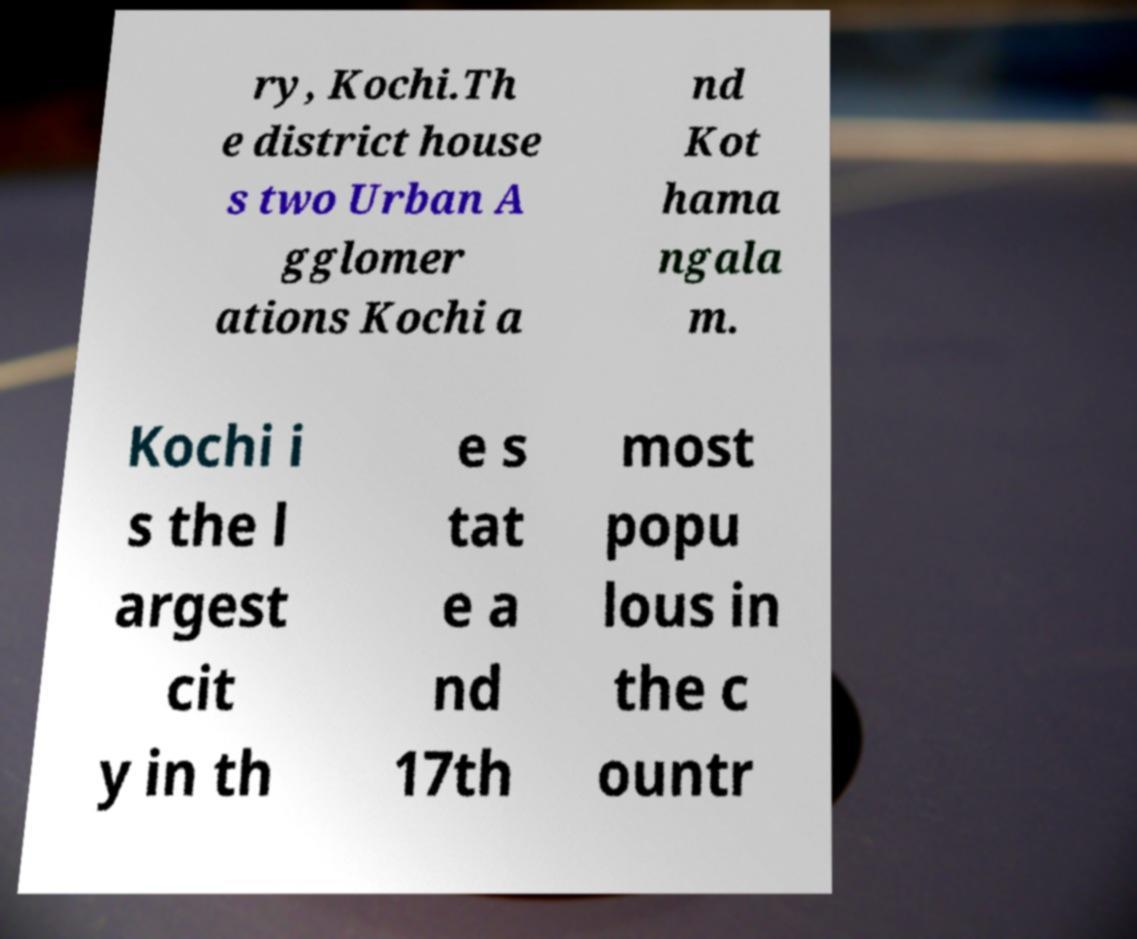For documentation purposes, I need the text within this image transcribed. Could you provide that? ry, Kochi.Th e district house s two Urban A gglomer ations Kochi a nd Kot hama ngala m. Kochi i s the l argest cit y in th e s tat e a nd 17th most popu lous in the c ountr 